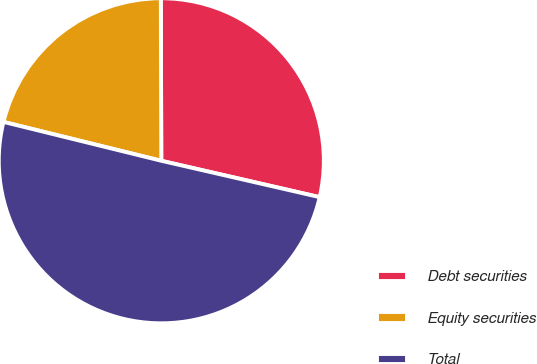Convert chart. <chart><loc_0><loc_0><loc_500><loc_500><pie_chart><fcel>Debt securities<fcel>Equity securities<fcel>Total<nl><fcel>28.64%<fcel>21.11%<fcel>50.25%<nl></chart> 